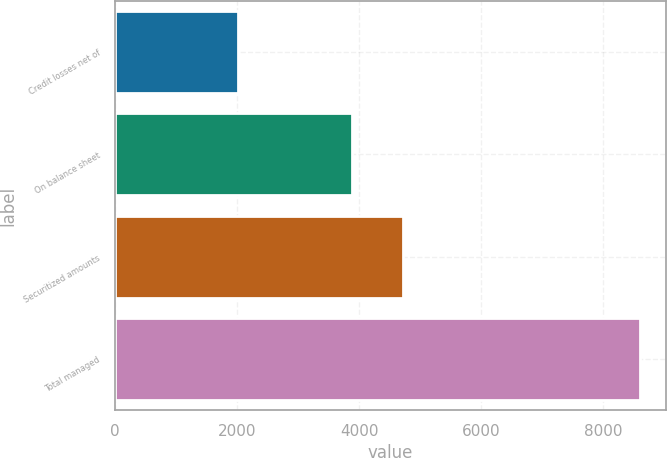Convert chart. <chart><loc_0><loc_0><loc_500><loc_500><bar_chart><fcel>Credit losses net of<fcel>On balance sheet<fcel>Securitized amounts<fcel>Total managed<nl><fcel>2007<fcel>3877<fcel>4728<fcel>8605<nl></chart> 